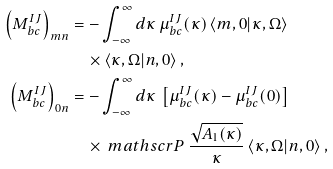<formula> <loc_0><loc_0><loc_500><loc_500>\left ( M ^ { I J } _ { b c } \right ) _ { m n } & = - \int _ { - \infty } ^ { \infty } d \kappa \, \mu _ { b c } ^ { I J } ( \kappa ) \, \langle m , 0 | \kappa , \Omega \rangle \, \\ & \quad \times \langle \kappa , \Omega | n , 0 \rangle \, , \\ \left ( M _ { b c } ^ { I J } \right ) _ { 0 n } & = - \int _ { - \infty } ^ { \infty } d \kappa \, \left [ \mu _ { b c } ^ { I J } ( \kappa ) - \mu _ { b c } ^ { I J } ( 0 ) \right ] \, \\ & \quad \times \ m a t h s c r { P } \, \frac { \sqrt { A _ { 1 } ( \kappa ) } } { \kappa } \, \langle \kappa , \Omega | n , 0 \rangle \, ,</formula> 